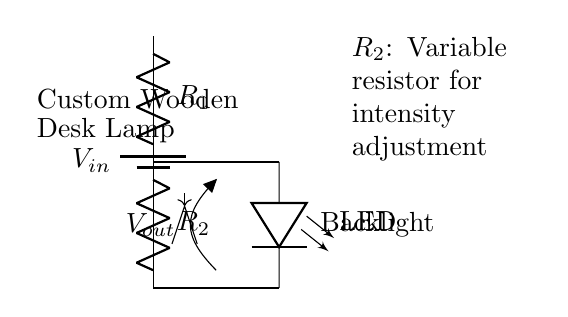What components are in this circuit? The circuit includes a battery, two resistors (one variable), a LED, and connections.
Answer: battery, resistors, LED What is the function of R2? R2 is a variable resistor, commonly referred to as a potentiometer in this case, used for adjusting the intensity of the LED backlight.
Answer: intensity adjustment What is Vout in relation to Vin? Vout is the output voltage taken across R2 in the voltage divider setup, which can vary depending on the values of R1 and R2.
Answer: Vout How many resistors are in the circuit? There are two resistors in the circuit: R1 and R2.
Answer: two What effect does increasing R2 have on LED brightness? Increasing R2 decreases Vout, leading to dimmer LED brightness, as it allows less current to flow through the LED.
Answer: dimmer What type of circuit is this? This is a voltage divider circuit, designed to control the output voltage for LED intensity adjustment.
Answer: voltage divider 